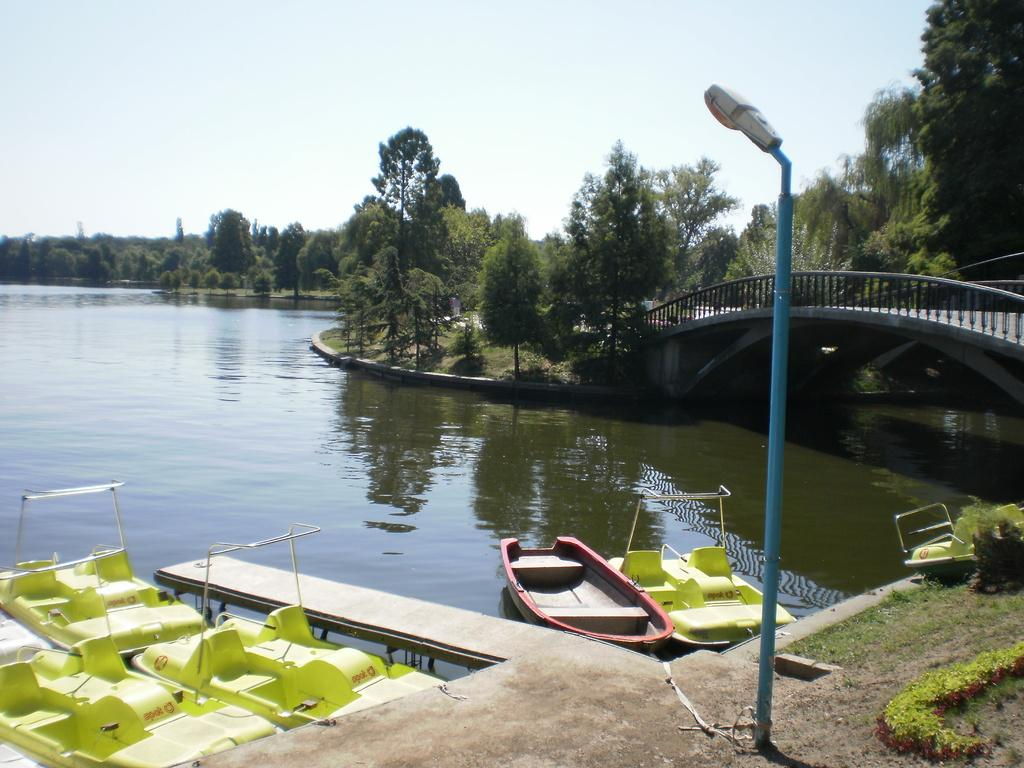What type of vehicles are in the image? There are small boats in the image. What color are the boats? The boats are green in color. What is visible at the bottom of the image? There is water visible at the bottom of the image. What structure can be seen to the right of the image? There is a bridge to the right of the image. What type of vegetation is visible in the background of the image? There are trees in the background of the image. What is visible at the top of the image? The sky is visible at the top of the image. How many daughters does the expert have at the camp in the image? There are no people, experts, or camps present in the image; it features small green boats, water, a bridge, trees, and the sky. 